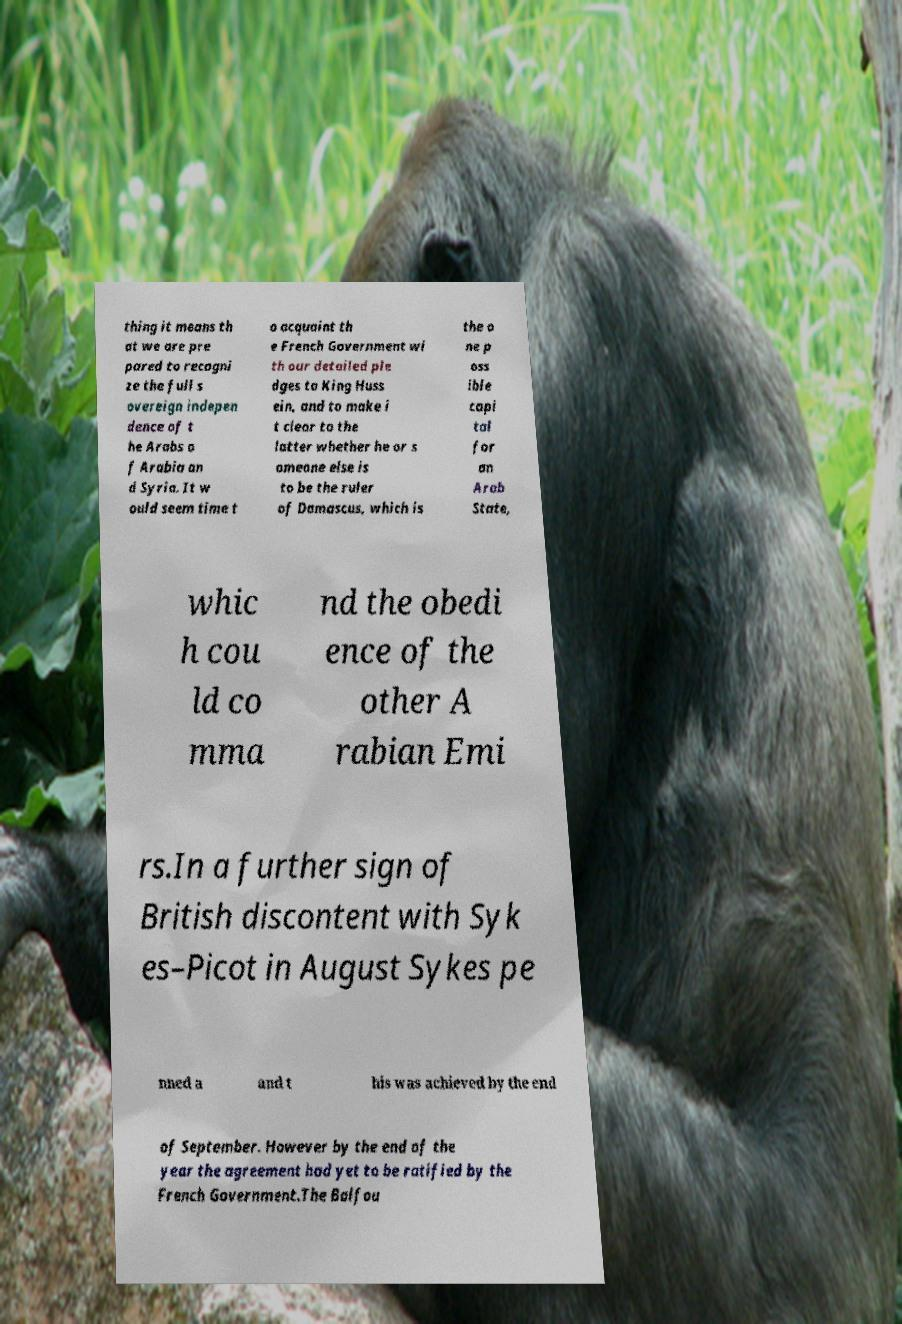I need the written content from this picture converted into text. Can you do that? thing it means th at we are pre pared to recogni ze the full s overeign indepen dence of t he Arabs o f Arabia an d Syria. It w ould seem time t o acquaint th e French Government wi th our detailed ple dges to King Huss ein, and to make i t clear to the latter whether he or s omeone else is to be the ruler of Damascus, which is the o ne p oss ible capi tal for an Arab State, whic h cou ld co mma nd the obedi ence of the other A rabian Emi rs.In a further sign of British discontent with Syk es–Picot in August Sykes pe nned a and t his was achieved by the end of September. However by the end of the year the agreement had yet to be ratified by the French Government.The Balfou 